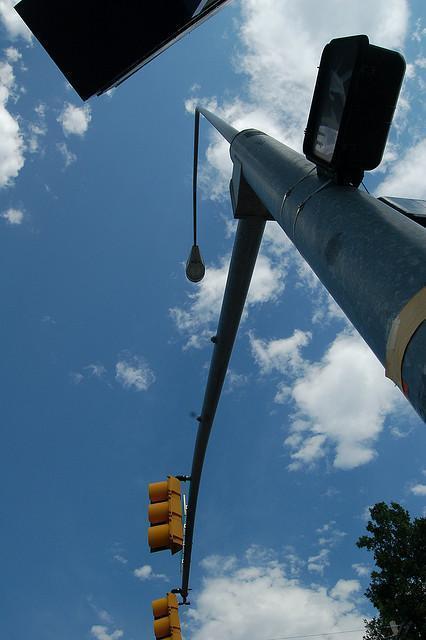How many traffic lights are visible?
Give a very brief answer. 2. 